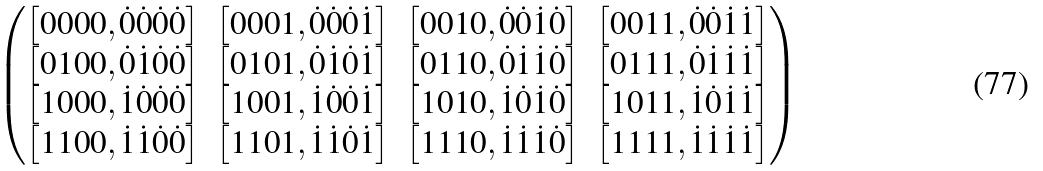<formula> <loc_0><loc_0><loc_500><loc_500>\begin{pmatrix} \left [ 0 0 0 0 , \dot { 0 } \dot { 0 } \dot { 0 } \dot { 0 } \right ] & \left [ 0 0 0 1 , \dot { 0 } \dot { 0 } \dot { 0 } \dot { 1 } \right ] & \left [ 0 0 1 0 , \dot { 0 } \dot { 0 } \dot { 1 } \dot { 0 } \right ] & \left [ 0 0 1 1 , \dot { 0 } \dot { 0 } \dot { 1 } \dot { 1 } \right ] \\ \left [ 0 1 0 0 , \dot { 0 } \dot { 1 } \dot { 0 } \dot { 0 } \right ] & \left [ 0 1 0 1 , \dot { 0 } \dot { 1 } \dot { 0 } \dot { 1 } \right ] & \left [ 0 1 1 0 , \dot { 0 } \dot { 1 } \dot { 1 } \dot { 0 } \right ] & \left [ 0 1 1 1 , \dot { 0 } \dot { 1 } \dot { 1 } \dot { 1 } \right ] \\ \left [ 1 0 0 0 , \dot { 1 } \dot { 0 } \dot { 0 } \dot { 0 } \right ] & \left [ 1 0 0 1 , \dot { 1 } \dot { 0 } \dot { 0 } \dot { 1 } \right ] & \left [ 1 0 1 0 , \dot { 1 } \dot { 0 } \dot { 1 } \dot { 0 } \right ] & \left [ 1 0 1 1 , \dot { 1 } \dot { 0 } \dot { 1 } \dot { 1 } \right ] \\ \left [ 1 1 0 0 , \dot { 1 } \dot { 1 } \dot { 0 } \dot { 0 } \right ] & \left [ 1 1 0 1 , \dot { 1 } \dot { 1 } \dot { 0 } \dot { 1 } \right ] & \left [ 1 1 1 0 , \dot { 1 } \dot { 1 } \dot { 1 } \dot { 0 } \right ] & \left [ 1 1 1 1 , \dot { 1 } \dot { 1 } \dot { 1 } \dot { 1 } \right ] \end{pmatrix}</formula> 